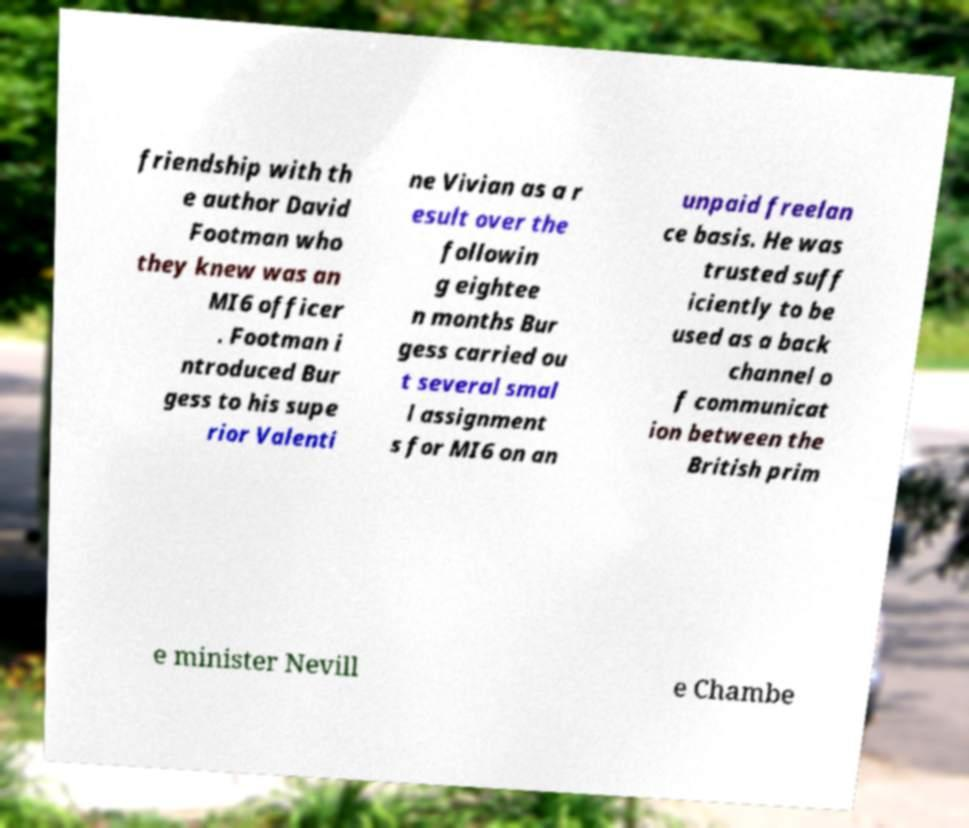For documentation purposes, I need the text within this image transcribed. Could you provide that? friendship with th e author David Footman who they knew was an MI6 officer . Footman i ntroduced Bur gess to his supe rior Valenti ne Vivian as a r esult over the followin g eightee n months Bur gess carried ou t several smal l assignment s for MI6 on an unpaid freelan ce basis. He was trusted suff iciently to be used as a back channel o f communicat ion between the British prim e minister Nevill e Chambe 